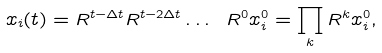Convert formula to latex. <formula><loc_0><loc_0><loc_500><loc_500>x _ { i } ( t ) = R ^ { t - \Delta t } R ^ { t - 2 \Delta t } \dots \ R ^ { 0 } x _ { i } ^ { 0 } = \prod _ { k } R ^ { k } x _ { i } ^ { 0 } ,</formula> 